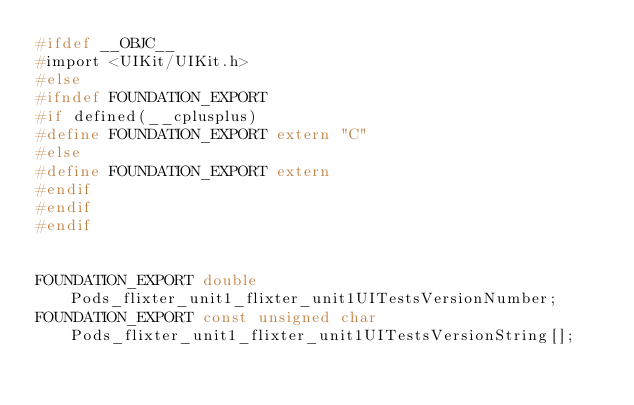<code> <loc_0><loc_0><loc_500><loc_500><_C_>#ifdef __OBJC__
#import <UIKit/UIKit.h>
#else
#ifndef FOUNDATION_EXPORT
#if defined(__cplusplus)
#define FOUNDATION_EXPORT extern "C"
#else
#define FOUNDATION_EXPORT extern
#endif
#endif
#endif


FOUNDATION_EXPORT double Pods_flixter_unit1_flixter_unit1UITestsVersionNumber;
FOUNDATION_EXPORT const unsigned char Pods_flixter_unit1_flixter_unit1UITestsVersionString[];

</code> 